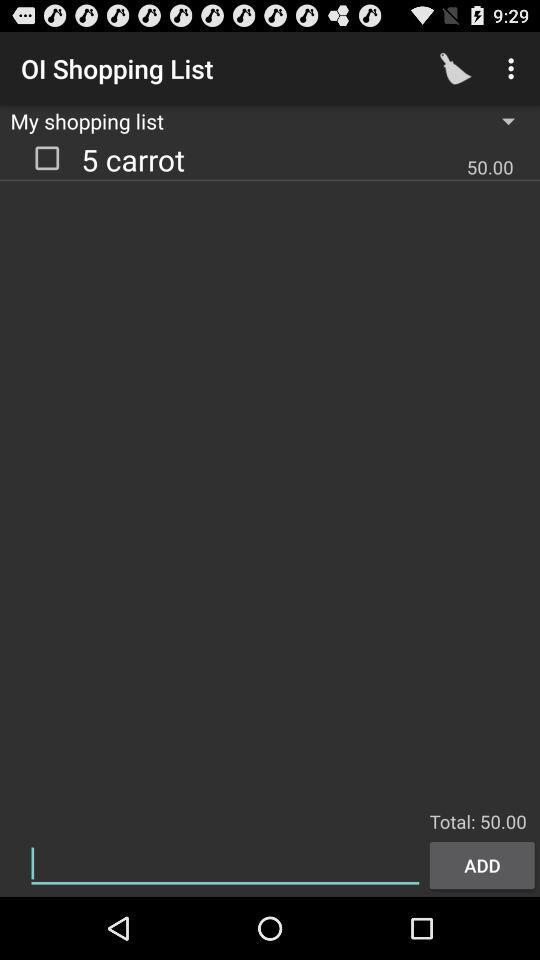What is the price of 5 carrots? The price of 5 carrot is 50.00. 